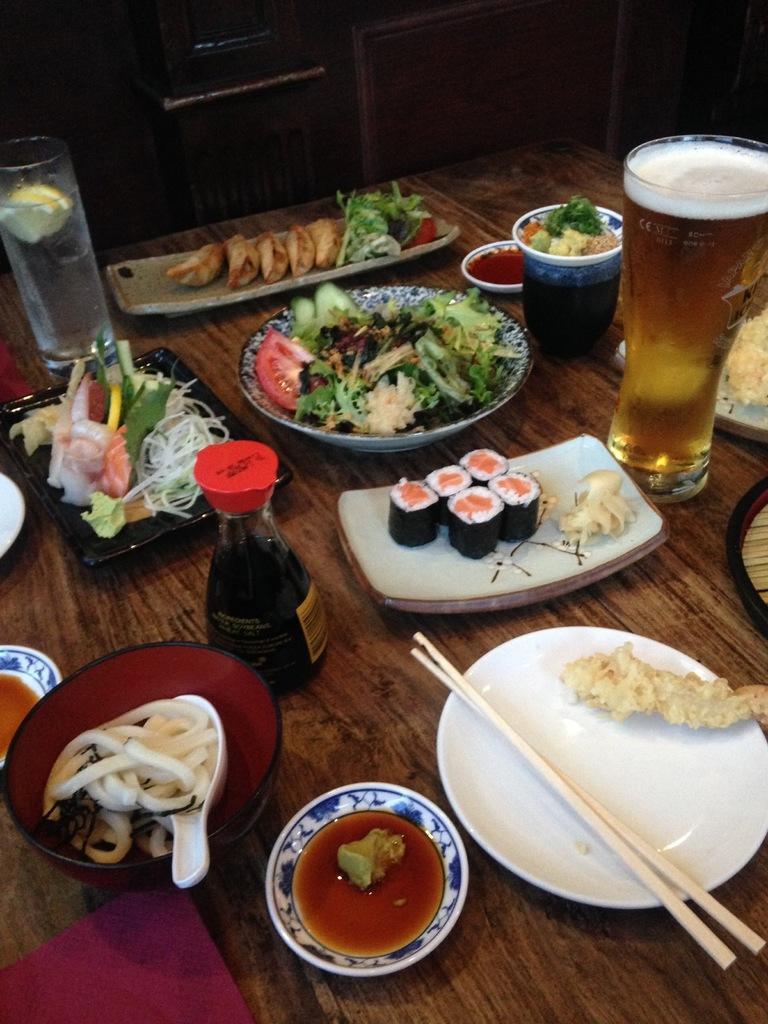In one or two sentences, can you explain what this image depicts? I can see in this image there are two glasses, plates, cups and other objects on the table. 